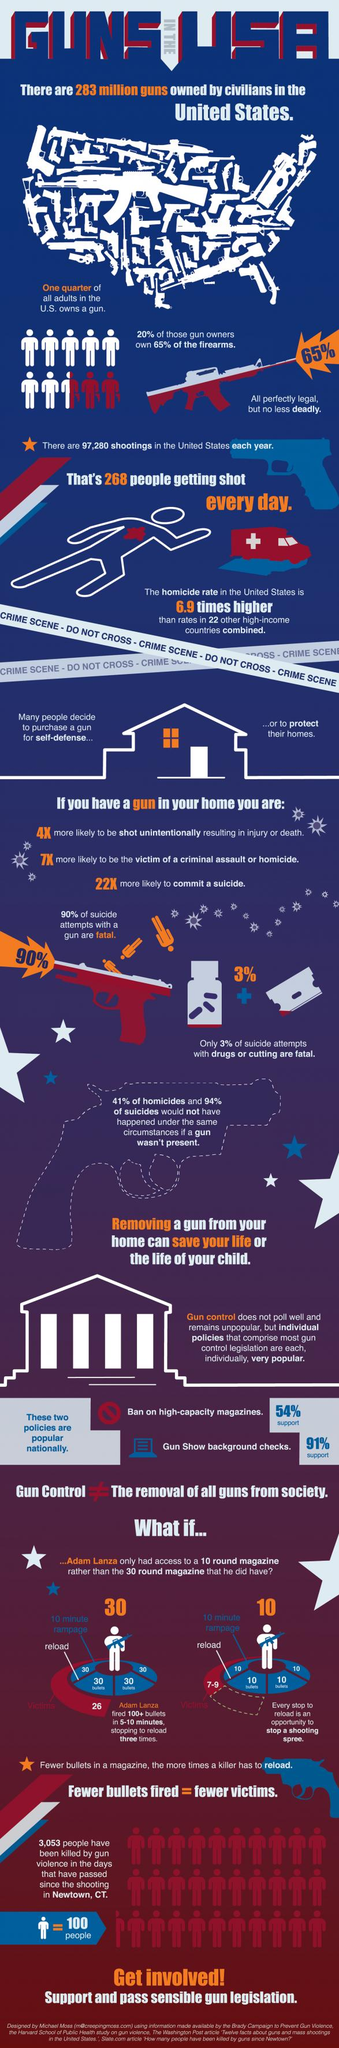Give some essential details in this illustration. According to recent data, an average of 97,280 gun shootings occur annually in the United States. The primary reasons why individuals in the United States acquire firearms are for self-defense and to safeguard their homes. It is reported that Adam Lanza reloaded his gun three times. According to a recent study, approximately 25% of adults in the US own a gun. There are approximately 268 shootings per day in the United States. 